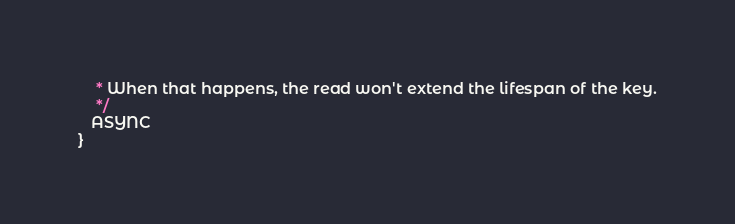Convert code to text. <code><loc_0><loc_0><loc_500><loc_500><_Java_>    * When that happens, the read won't extend the lifespan of the key.
    */
   ASYNC
}
</code> 